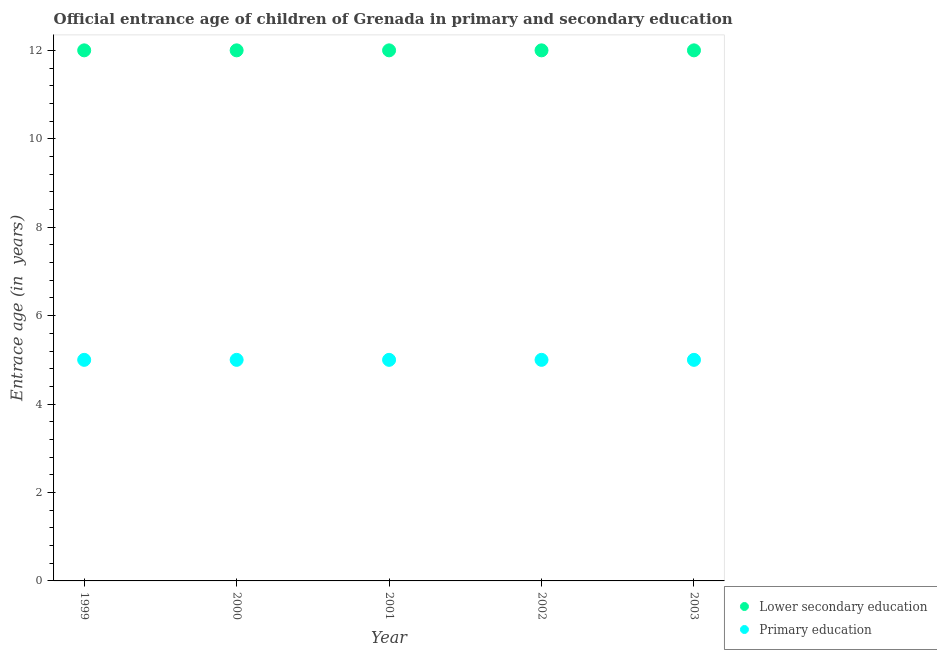Is the number of dotlines equal to the number of legend labels?
Offer a very short reply. Yes. What is the entrance age of children in lower secondary education in 1999?
Give a very brief answer. 12. Across all years, what is the maximum entrance age of children in lower secondary education?
Provide a succinct answer. 12. Across all years, what is the minimum entrance age of chiildren in primary education?
Your response must be concise. 5. In which year was the entrance age of chiildren in primary education minimum?
Your answer should be very brief. 1999. What is the total entrance age of chiildren in primary education in the graph?
Keep it short and to the point. 25. What is the difference between the entrance age of chiildren in primary education in 2001 and that in 2002?
Make the answer very short. 0. What is the difference between the entrance age of chiildren in primary education in 1999 and the entrance age of children in lower secondary education in 2000?
Your answer should be very brief. -7. What is the average entrance age of chiildren in primary education per year?
Keep it short and to the point. 5. In the year 1999, what is the difference between the entrance age of chiildren in primary education and entrance age of children in lower secondary education?
Your response must be concise. -7. In how many years, is the entrance age of children in lower secondary education greater than 5.2 years?
Offer a very short reply. 5. What is the ratio of the entrance age of children in lower secondary education in 2001 to that in 2003?
Offer a very short reply. 1. Is the entrance age of chiildren in primary education in 1999 less than that in 2003?
Ensure brevity in your answer.  No. What is the difference between the highest and the lowest entrance age of children in lower secondary education?
Keep it short and to the point. 0. Is the entrance age of children in lower secondary education strictly less than the entrance age of chiildren in primary education over the years?
Keep it short and to the point. No. How many years are there in the graph?
Your answer should be very brief. 5. Does the graph contain grids?
Provide a short and direct response. No. How are the legend labels stacked?
Keep it short and to the point. Vertical. What is the title of the graph?
Provide a short and direct response. Official entrance age of children of Grenada in primary and secondary education. What is the label or title of the Y-axis?
Offer a terse response. Entrace age (in  years). What is the Entrace age (in  years) of Lower secondary education in 1999?
Your answer should be compact. 12. What is the Entrace age (in  years) of Lower secondary education in 2000?
Offer a terse response. 12. What is the Entrace age (in  years) in Lower secondary education in 2001?
Your answer should be very brief. 12. What is the Entrace age (in  years) in Primary education in 2001?
Your answer should be compact. 5. What is the Entrace age (in  years) of Lower secondary education in 2002?
Offer a terse response. 12. What is the Entrace age (in  years) in Lower secondary education in 2003?
Your answer should be very brief. 12. Across all years, what is the maximum Entrace age (in  years) in Primary education?
Your answer should be compact. 5. What is the difference between the Entrace age (in  years) of Lower secondary education in 1999 and that in 2000?
Your answer should be very brief. 0. What is the difference between the Entrace age (in  years) of Primary education in 1999 and that in 2001?
Give a very brief answer. 0. What is the difference between the Entrace age (in  years) of Lower secondary education in 1999 and that in 2002?
Provide a short and direct response. 0. What is the difference between the Entrace age (in  years) of Lower secondary education in 1999 and that in 2003?
Give a very brief answer. 0. What is the difference between the Entrace age (in  years) of Lower secondary education in 2000 and that in 2001?
Offer a terse response. 0. What is the difference between the Entrace age (in  years) in Primary education in 2000 and that in 2001?
Give a very brief answer. 0. What is the difference between the Entrace age (in  years) of Lower secondary education in 2000 and that in 2002?
Give a very brief answer. 0. What is the difference between the Entrace age (in  years) of Primary education in 2000 and that in 2003?
Make the answer very short. 0. What is the difference between the Entrace age (in  years) in Lower secondary education in 2001 and that in 2002?
Your answer should be very brief. 0. What is the difference between the Entrace age (in  years) in Primary education in 2001 and that in 2002?
Make the answer very short. 0. What is the difference between the Entrace age (in  years) in Lower secondary education in 2001 and that in 2003?
Keep it short and to the point. 0. What is the difference between the Entrace age (in  years) in Primary education in 2001 and that in 2003?
Give a very brief answer. 0. What is the difference between the Entrace age (in  years) of Lower secondary education in 2002 and that in 2003?
Make the answer very short. 0. What is the difference between the Entrace age (in  years) of Lower secondary education in 1999 and the Entrace age (in  years) of Primary education in 2001?
Offer a terse response. 7. What is the difference between the Entrace age (in  years) in Lower secondary education in 2000 and the Entrace age (in  years) in Primary education in 2001?
Provide a succinct answer. 7. What is the difference between the Entrace age (in  years) of Lower secondary education in 2000 and the Entrace age (in  years) of Primary education in 2002?
Give a very brief answer. 7. What is the difference between the Entrace age (in  years) in Lower secondary education in 2000 and the Entrace age (in  years) in Primary education in 2003?
Offer a very short reply. 7. What is the difference between the Entrace age (in  years) of Lower secondary education in 2001 and the Entrace age (in  years) of Primary education in 2003?
Your answer should be compact. 7. What is the average Entrace age (in  years) of Lower secondary education per year?
Your answer should be very brief. 12. What is the average Entrace age (in  years) in Primary education per year?
Offer a very short reply. 5. In the year 1999, what is the difference between the Entrace age (in  years) of Lower secondary education and Entrace age (in  years) of Primary education?
Your answer should be compact. 7. In the year 2002, what is the difference between the Entrace age (in  years) of Lower secondary education and Entrace age (in  years) of Primary education?
Your response must be concise. 7. What is the ratio of the Entrace age (in  years) in Primary education in 1999 to that in 2000?
Ensure brevity in your answer.  1. What is the ratio of the Entrace age (in  years) of Lower secondary education in 1999 to that in 2003?
Offer a terse response. 1. What is the ratio of the Entrace age (in  years) of Primary education in 1999 to that in 2003?
Your answer should be very brief. 1. What is the ratio of the Entrace age (in  years) in Primary education in 2000 to that in 2001?
Provide a short and direct response. 1. What is the ratio of the Entrace age (in  years) in Lower secondary education in 2000 to that in 2002?
Ensure brevity in your answer.  1. What is the ratio of the Entrace age (in  years) of Primary education in 2000 to that in 2002?
Keep it short and to the point. 1. What is the ratio of the Entrace age (in  years) of Lower secondary education in 2000 to that in 2003?
Your answer should be very brief. 1. What is the ratio of the Entrace age (in  years) in Lower secondary education in 2001 to that in 2002?
Keep it short and to the point. 1. What is the ratio of the Entrace age (in  years) of Primary education in 2001 to that in 2002?
Provide a succinct answer. 1. What is the ratio of the Entrace age (in  years) in Primary education in 2002 to that in 2003?
Ensure brevity in your answer.  1. 